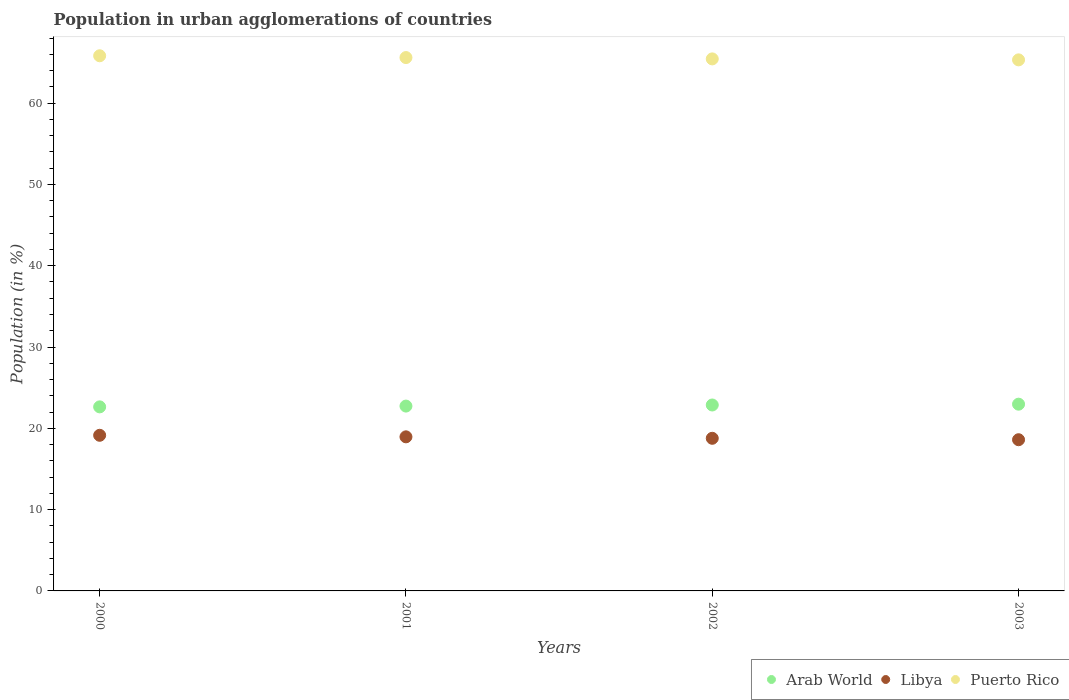What is the percentage of population in urban agglomerations in Arab World in 2003?
Your answer should be very brief. 22.97. Across all years, what is the maximum percentage of population in urban agglomerations in Puerto Rico?
Provide a short and direct response. 65.82. Across all years, what is the minimum percentage of population in urban agglomerations in Arab World?
Ensure brevity in your answer.  22.64. In which year was the percentage of population in urban agglomerations in Puerto Rico minimum?
Keep it short and to the point. 2003. What is the total percentage of population in urban agglomerations in Arab World in the graph?
Your response must be concise. 91.21. What is the difference between the percentage of population in urban agglomerations in Libya in 2000 and that in 2001?
Provide a short and direct response. 0.19. What is the difference between the percentage of population in urban agglomerations in Arab World in 2003 and the percentage of population in urban agglomerations in Libya in 2001?
Provide a succinct answer. 4.02. What is the average percentage of population in urban agglomerations in Arab World per year?
Make the answer very short. 22.8. In the year 2002, what is the difference between the percentage of population in urban agglomerations in Arab World and percentage of population in urban agglomerations in Puerto Rico?
Keep it short and to the point. -42.57. What is the ratio of the percentage of population in urban agglomerations in Puerto Rico in 2000 to that in 2001?
Offer a very short reply. 1. What is the difference between the highest and the second highest percentage of population in urban agglomerations in Libya?
Keep it short and to the point. 0.19. What is the difference between the highest and the lowest percentage of population in urban agglomerations in Libya?
Offer a terse response. 0.54. Is the sum of the percentage of population in urban agglomerations in Libya in 2001 and 2003 greater than the maximum percentage of population in urban agglomerations in Puerto Rico across all years?
Make the answer very short. No. Is it the case that in every year, the sum of the percentage of population in urban agglomerations in Libya and percentage of population in urban agglomerations in Arab World  is greater than the percentage of population in urban agglomerations in Puerto Rico?
Offer a terse response. No. Does the percentage of population in urban agglomerations in Libya monotonically increase over the years?
Offer a terse response. No. What is the difference between two consecutive major ticks on the Y-axis?
Your answer should be very brief. 10. Are the values on the major ticks of Y-axis written in scientific E-notation?
Offer a terse response. No. Does the graph contain any zero values?
Provide a succinct answer. No. Does the graph contain grids?
Make the answer very short. No. Where does the legend appear in the graph?
Your response must be concise. Bottom right. How many legend labels are there?
Ensure brevity in your answer.  3. What is the title of the graph?
Your answer should be very brief. Population in urban agglomerations of countries. Does "Central Europe" appear as one of the legend labels in the graph?
Your response must be concise. No. What is the label or title of the X-axis?
Provide a succinct answer. Years. What is the Population (in %) in Arab World in 2000?
Provide a succinct answer. 22.64. What is the Population (in %) of Libya in 2000?
Make the answer very short. 19.14. What is the Population (in %) of Puerto Rico in 2000?
Your response must be concise. 65.82. What is the Population (in %) in Arab World in 2001?
Offer a very short reply. 22.74. What is the Population (in %) in Libya in 2001?
Your answer should be compact. 18.95. What is the Population (in %) in Puerto Rico in 2001?
Give a very brief answer. 65.6. What is the Population (in %) in Arab World in 2002?
Your answer should be compact. 22.87. What is the Population (in %) in Libya in 2002?
Provide a succinct answer. 18.77. What is the Population (in %) of Puerto Rico in 2002?
Give a very brief answer. 65.44. What is the Population (in %) of Arab World in 2003?
Your response must be concise. 22.97. What is the Population (in %) in Libya in 2003?
Keep it short and to the point. 18.6. What is the Population (in %) in Puerto Rico in 2003?
Offer a terse response. 65.32. Across all years, what is the maximum Population (in %) in Arab World?
Provide a short and direct response. 22.97. Across all years, what is the maximum Population (in %) in Libya?
Give a very brief answer. 19.14. Across all years, what is the maximum Population (in %) of Puerto Rico?
Offer a terse response. 65.82. Across all years, what is the minimum Population (in %) of Arab World?
Offer a terse response. 22.64. Across all years, what is the minimum Population (in %) in Libya?
Provide a succinct answer. 18.6. Across all years, what is the minimum Population (in %) in Puerto Rico?
Provide a succinct answer. 65.32. What is the total Population (in %) in Arab World in the graph?
Offer a very short reply. 91.21. What is the total Population (in %) of Libya in the graph?
Your answer should be compact. 75.46. What is the total Population (in %) of Puerto Rico in the graph?
Your answer should be compact. 262.19. What is the difference between the Population (in %) in Arab World in 2000 and that in 2001?
Your answer should be compact. -0.1. What is the difference between the Population (in %) of Libya in 2000 and that in 2001?
Make the answer very short. 0.19. What is the difference between the Population (in %) in Puerto Rico in 2000 and that in 2001?
Make the answer very short. 0.22. What is the difference between the Population (in %) in Arab World in 2000 and that in 2002?
Keep it short and to the point. -0.23. What is the difference between the Population (in %) of Libya in 2000 and that in 2002?
Ensure brevity in your answer.  0.37. What is the difference between the Population (in %) in Puerto Rico in 2000 and that in 2002?
Your response must be concise. 0.38. What is the difference between the Population (in %) of Arab World in 2000 and that in 2003?
Provide a succinct answer. -0.33. What is the difference between the Population (in %) in Libya in 2000 and that in 2003?
Your response must be concise. 0.54. What is the difference between the Population (in %) in Puerto Rico in 2000 and that in 2003?
Offer a very short reply. 0.5. What is the difference between the Population (in %) in Arab World in 2001 and that in 2002?
Provide a short and direct response. -0.13. What is the difference between the Population (in %) in Libya in 2001 and that in 2002?
Your response must be concise. 0.18. What is the difference between the Population (in %) of Puerto Rico in 2001 and that in 2002?
Your answer should be very brief. 0.16. What is the difference between the Population (in %) of Arab World in 2001 and that in 2003?
Provide a short and direct response. -0.23. What is the difference between the Population (in %) in Libya in 2001 and that in 2003?
Provide a succinct answer. 0.35. What is the difference between the Population (in %) in Puerto Rico in 2001 and that in 2003?
Your response must be concise. 0.28. What is the difference between the Population (in %) in Arab World in 2002 and that in 2003?
Make the answer very short. -0.1. What is the difference between the Population (in %) of Libya in 2002 and that in 2003?
Give a very brief answer. 0.18. What is the difference between the Population (in %) of Puerto Rico in 2002 and that in 2003?
Your response must be concise. 0.12. What is the difference between the Population (in %) in Arab World in 2000 and the Population (in %) in Libya in 2001?
Keep it short and to the point. 3.69. What is the difference between the Population (in %) of Arab World in 2000 and the Population (in %) of Puerto Rico in 2001?
Make the answer very short. -42.96. What is the difference between the Population (in %) of Libya in 2000 and the Population (in %) of Puerto Rico in 2001?
Keep it short and to the point. -46.46. What is the difference between the Population (in %) of Arab World in 2000 and the Population (in %) of Libya in 2002?
Give a very brief answer. 3.87. What is the difference between the Population (in %) of Arab World in 2000 and the Population (in %) of Puerto Rico in 2002?
Your response must be concise. -42.8. What is the difference between the Population (in %) in Libya in 2000 and the Population (in %) in Puerto Rico in 2002?
Ensure brevity in your answer.  -46.3. What is the difference between the Population (in %) in Arab World in 2000 and the Population (in %) in Libya in 2003?
Your answer should be very brief. 4.04. What is the difference between the Population (in %) of Arab World in 2000 and the Population (in %) of Puerto Rico in 2003?
Provide a short and direct response. -42.68. What is the difference between the Population (in %) of Libya in 2000 and the Population (in %) of Puerto Rico in 2003?
Provide a short and direct response. -46.18. What is the difference between the Population (in %) of Arab World in 2001 and the Population (in %) of Libya in 2002?
Keep it short and to the point. 3.96. What is the difference between the Population (in %) in Arab World in 2001 and the Population (in %) in Puerto Rico in 2002?
Your answer should be compact. -42.7. What is the difference between the Population (in %) of Libya in 2001 and the Population (in %) of Puerto Rico in 2002?
Provide a succinct answer. -46.49. What is the difference between the Population (in %) of Arab World in 2001 and the Population (in %) of Libya in 2003?
Your response must be concise. 4.14. What is the difference between the Population (in %) of Arab World in 2001 and the Population (in %) of Puerto Rico in 2003?
Your answer should be compact. -42.58. What is the difference between the Population (in %) of Libya in 2001 and the Population (in %) of Puerto Rico in 2003?
Offer a very short reply. -46.37. What is the difference between the Population (in %) in Arab World in 2002 and the Population (in %) in Libya in 2003?
Offer a very short reply. 4.27. What is the difference between the Population (in %) in Arab World in 2002 and the Population (in %) in Puerto Rico in 2003?
Make the answer very short. -42.45. What is the difference between the Population (in %) in Libya in 2002 and the Population (in %) in Puerto Rico in 2003?
Offer a terse response. -46.55. What is the average Population (in %) of Arab World per year?
Your response must be concise. 22.8. What is the average Population (in %) of Libya per year?
Your answer should be very brief. 18.87. What is the average Population (in %) of Puerto Rico per year?
Offer a terse response. 65.55. In the year 2000, what is the difference between the Population (in %) in Arab World and Population (in %) in Libya?
Provide a short and direct response. 3.5. In the year 2000, what is the difference between the Population (in %) of Arab World and Population (in %) of Puerto Rico?
Ensure brevity in your answer.  -43.18. In the year 2000, what is the difference between the Population (in %) of Libya and Population (in %) of Puerto Rico?
Give a very brief answer. -46.68. In the year 2001, what is the difference between the Population (in %) in Arab World and Population (in %) in Libya?
Offer a terse response. 3.78. In the year 2001, what is the difference between the Population (in %) in Arab World and Population (in %) in Puerto Rico?
Your response must be concise. -42.87. In the year 2001, what is the difference between the Population (in %) in Libya and Population (in %) in Puerto Rico?
Keep it short and to the point. -46.65. In the year 2002, what is the difference between the Population (in %) of Arab World and Population (in %) of Libya?
Make the answer very short. 4.1. In the year 2002, what is the difference between the Population (in %) of Arab World and Population (in %) of Puerto Rico?
Ensure brevity in your answer.  -42.57. In the year 2002, what is the difference between the Population (in %) in Libya and Population (in %) in Puerto Rico?
Your answer should be compact. -46.67. In the year 2003, what is the difference between the Population (in %) of Arab World and Population (in %) of Libya?
Your answer should be compact. 4.37. In the year 2003, what is the difference between the Population (in %) of Arab World and Population (in %) of Puerto Rico?
Offer a very short reply. -42.35. In the year 2003, what is the difference between the Population (in %) in Libya and Population (in %) in Puerto Rico?
Make the answer very short. -46.72. What is the ratio of the Population (in %) of Arab World in 2000 to that in 2001?
Offer a very short reply. 1. What is the ratio of the Population (in %) in Puerto Rico in 2000 to that in 2001?
Your answer should be very brief. 1. What is the ratio of the Population (in %) of Libya in 2000 to that in 2002?
Provide a succinct answer. 1.02. What is the ratio of the Population (in %) of Puerto Rico in 2000 to that in 2002?
Give a very brief answer. 1.01. What is the ratio of the Population (in %) of Arab World in 2000 to that in 2003?
Make the answer very short. 0.99. What is the ratio of the Population (in %) in Libya in 2000 to that in 2003?
Offer a terse response. 1.03. What is the ratio of the Population (in %) in Puerto Rico in 2000 to that in 2003?
Provide a short and direct response. 1.01. What is the ratio of the Population (in %) in Arab World in 2001 to that in 2002?
Provide a succinct answer. 0.99. What is the ratio of the Population (in %) of Libya in 2001 to that in 2002?
Give a very brief answer. 1.01. What is the ratio of the Population (in %) of Puerto Rico in 2001 to that in 2002?
Ensure brevity in your answer.  1. What is the ratio of the Population (in %) of Arab World in 2001 to that in 2003?
Keep it short and to the point. 0.99. What is the ratio of the Population (in %) in Libya in 2001 to that in 2003?
Provide a short and direct response. 1.02. What is the ratio of the Population (in %) in Puerto Rico in 2001 to that in 2003?
Give a very brief answer. 1. What is the ratio of the Population (in %) of Libya in 2002 to that in 2003?
Give a very brief answer. 1.01. What is the ratio of the Population (in %) of Puerto Rico in 2002 to that in 2003?
Provide a short and direct response. 1. What is the difference between the highest and the second highest Population (in %) of Arab World?
Give a very brief answer. 0.1. What is the difference between the highest and the second highest Population (in %) in Libya?
Make the answer very short. 0.19. What is the difference between the highest and the second highest Population (in %) of Puerto Rico?
Provide a succinct answer. 0.22. What is the difference between the highest and the lowest Population (in %) in Arab World?
Provide a succinct answer. 0.33. What is the difference between the highest and the lowest Population (in %) of Libya?
Ensure brevity in your answer.  0.54. What is the difference between the highest and the lowest Population (in %) in Puerto Rico?
Provide a short and direct response. 0.5. 